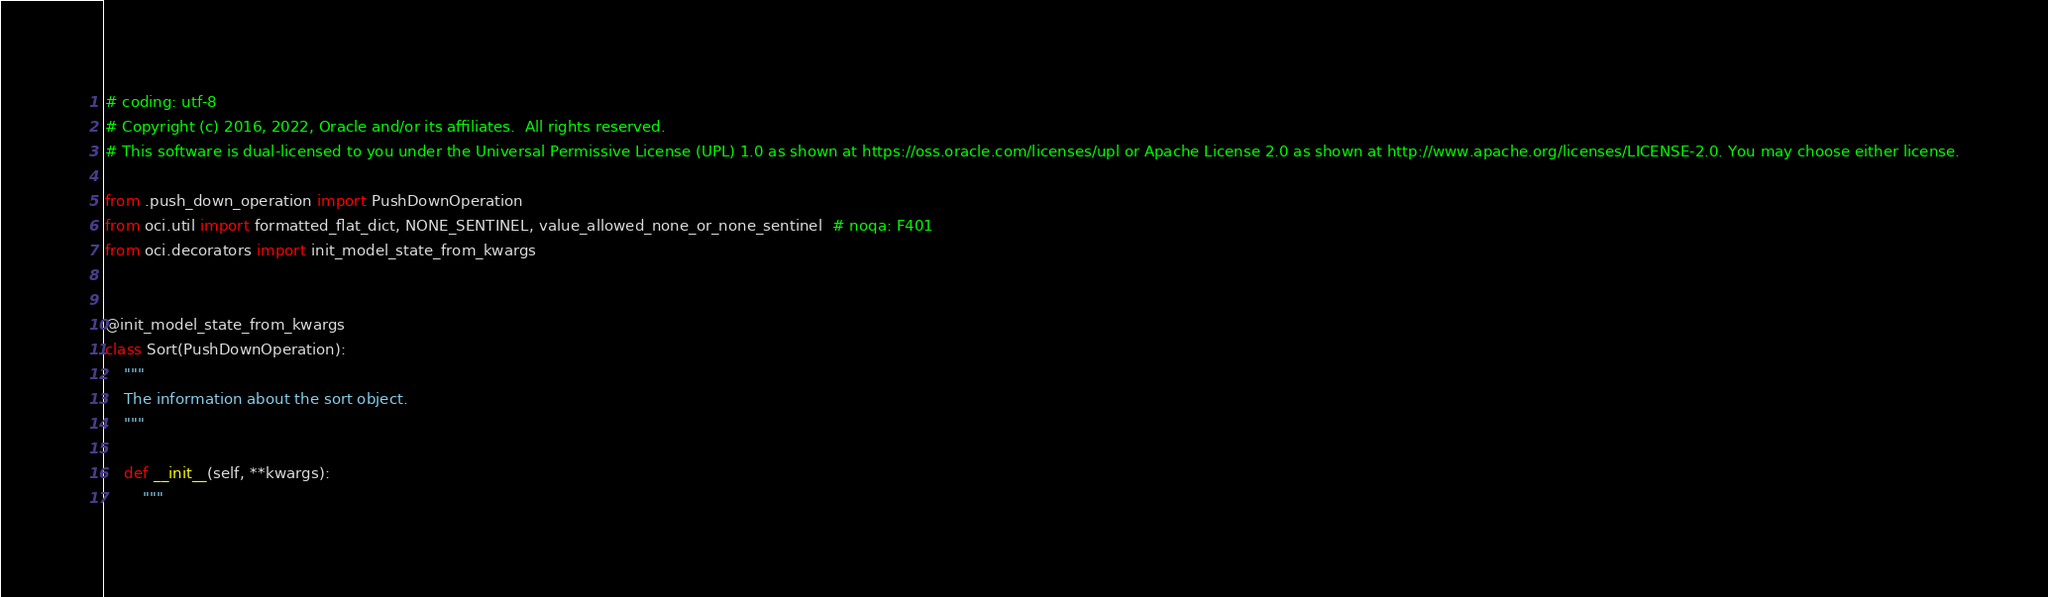<code> <loc_0><loc_0><loc_500><loc_500><_Python_># coding: utf-8
# Copyright (c) 2016, 2022, Oracle and/or its affiliates.  All rights reserved.
# This software is dual-licensed to you under the Universal Permissive License (UPL) 1.0 as shown at https://oss.oracle.com/licenses/upl or Apache License 2.0 as shown at http://www.apache.org/licenses/LICENSE-2.0. You may choose either license.

from .push_down_operation import PushDownOperation
from oci.util import formatted_flat_dict, NONE_SENTINEL, value_allowed_none_or_none_sentinel  # noqa: F401
from oci.decorators import init_model_state_from_kwargs


@init_model_state_from_kwargs
class Sort(PushDownOperation):
    """
    The information about the sort object.
    """

    def __init__(self, **kwargs):
        """</code> 